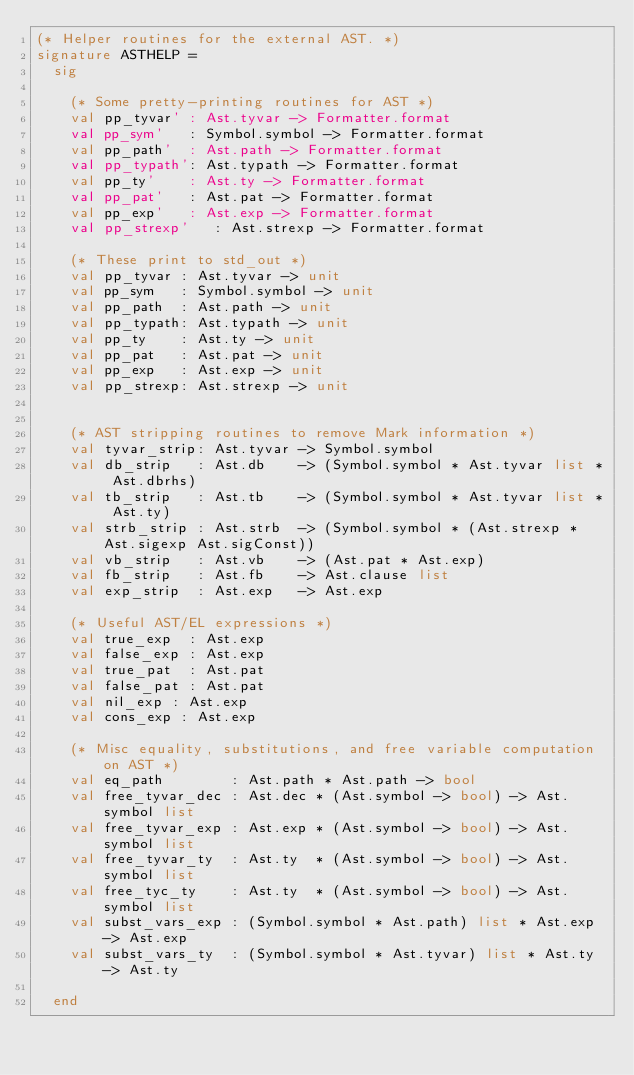<code> <loc_0><loc_0><loc_500><loc_500><_SML_>(* Helper routines for the external AST. *)
signature ASTHELP =
  sig

    (* Some pretty-printing routines for AST *)
    val pp_tyvar' : Ast.tyvar -> Formatter.format
    val pp_sym'   : Symbol.symbol -> Formatter.format
    val pp_path'  : Ast.path -> Formatter.format
    val pp_typath': Ast.typath -> Formatter.format
    val pp_ty'    : Ast.ty -> Formatter.format
    val pp_pat'   : Ast.pat -> Formatter.format
    val pp_exp'   : Ast.exp -> Formatter.format
    val pp_strexp'   : Ast.strexp -> Formatter.format

    (* These print to std_out *)
    val pp_tyvar : Ast.tyvar -> unit
    val pp_sym   : Symbol.symbol -> unit
    val pp_path  : Ast.path -> unit
    val pp_typath: Ast.typath -> unit
    val pp_ty    : Ast.ty -> unit
    val pp_pat   : Ast.pat -> unit
    val pp_exp   : Ast.exp -> unit
    val pp_strexp: Ast.strexp -> unit


    (* AST stripping routines to remove Mark information *)
    val tyvar_strip: Ast.tyvar -> Symbol.symbol
    val db_strip   : Ast.db    -> (Symbol.symbol * Ast.tyvar list * Ast.dbrhs)
    val tb_strip   : Ast.tb    -> (Symbol.symbol * Ast.tyvar list * Ast.ty)
    val strb_strip : Ast.strb  -> (Symbol.symbol * (Ast.strexp * Ast.sigexp Ast.sigConst))
    val vb_strip   : Ast.vb    -> (Ast.pat * Ast.exp)
    val fb_strip   : Ast.fb    -> Ast.clause list
    val exp_strip  : Ast.exp   -> Ast.exp

    (* Useful AST/EL expressions *)
    val true_exp  : Ast.exp
    val false_exp : Ast.exp
    val true_pat  : Ast.pat
    val false_pat : Ast.pat
    val nil_exp : Ast.exp
    val cons_exp : Ast.exp

    (* Misc equality, substitutions, and free variable computation on AST *)
    val eq_path        : Ast.path * Ast.path -> bool
    val free_tyvar_dec : Ast.dec * (Ast.symbol -> bool) -> Ast.symbol list
    val free_tyvar_exp : Ast.exp * (Ast.symbol -> bool) -> Ast.symbol list
    val free_tyvar_ty  : Ast.ty  * (Ast.symbol -> bool) -> Ast.symbol list
    val free_tyc_ty    : Ast.ty  * (Ast.symbol -> bool) -> Ast.symbol list
    val subst_vars_exp : (Symbol.symbol * Ast.path) list * Ast.exp -> Ast.exp
    val subst_vars_ty  : (Symbol.symbol * Ast.tyvar) list * Ast.ty -> Ast.ty

  end
</code> 